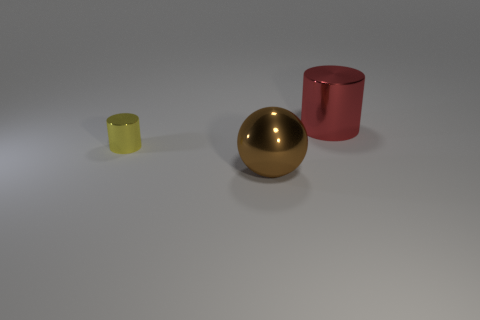There is a big metallic thing on the right side of the large metal thing on the left side of the large metal cylinder; what number of cylinders are in front of it?
Your response must be concise. 1. What color is the large ball that is the same material as the small yellow cylinder?
Your response must be concise. Brown. Is the size of the metal cylinder that is to the left of the red thing the same as the large brown metal ball?
Your response must be concise. No. What number of objects are either metal things or yellow shiny cylinders?
Your answer should be compact. 3. There is a thing that is on the right side of the big object on the left side of the big metallic thing behind the yellow cylinder; what is its material?
Offer a terse response. Metal. What is the cylinder behind the small metal object made of?
Your answer should be compact. Metal. Is there a yellow object of the same size as the yellow metal cylinder?
Give a very brief answer. No. There is a cylinder in front of the large cylinder; is its color the same as the large metallic cylinder?
Provide a succinct answer. No. How many blue objects are big balls or tiny metal spheres?
Your answer should be very brief. 0. What number of other metal cylinders are the same color as the small metal cylinder?
Provide a succinct answer. 0. 